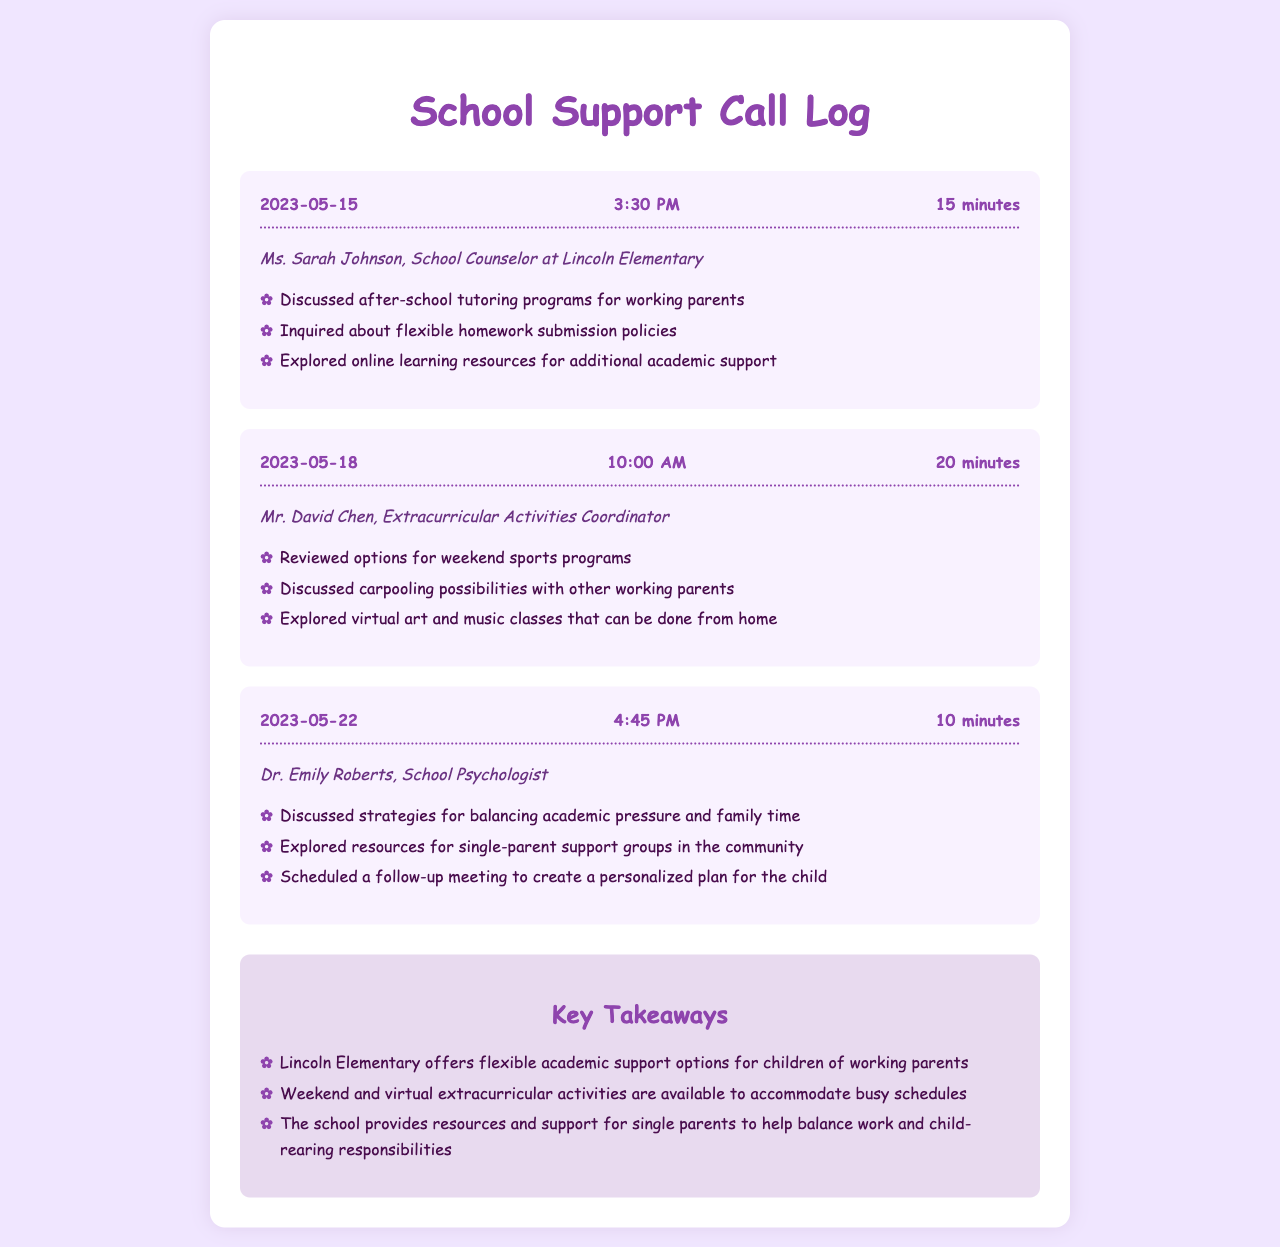What is the date of the first call? The first call recorded in the document took place on May 15, 2023.
Answer: May 15, 2023 Who did the second call involve? The second call was with Mr. David Chen, the Extracurricular Activities Coordinator.
Answer: Mr. David Chen How long was the last call? The last call lasted for 10 minutes, as noted in the call duration.
Answer: 10 minutes What academic support option was discussed in the first call? After-school tutoring programs were mentioned during the first call with the school counselor.
Answer: after-school tutoring programs Which extracurricular activity options were explored in the second call? Weekend sports programs were reviewed as part of the extracurricular options in the second call.
Answer: weekend sports programs What resource type was discussed during the third call? Single-parent support groups were discussed as resources available in the community during the third call.
Answer: single-parent support groups What needs does the document address for working parents? The document addresses the need for academic and extracurricular support for children of working parents.
Answer: academic and extracurricular support What is the primary focus of the call logs? The primary focus is on discussing academic support and extracurricular activities for children.
Answer: academic support and extracurricular activities 